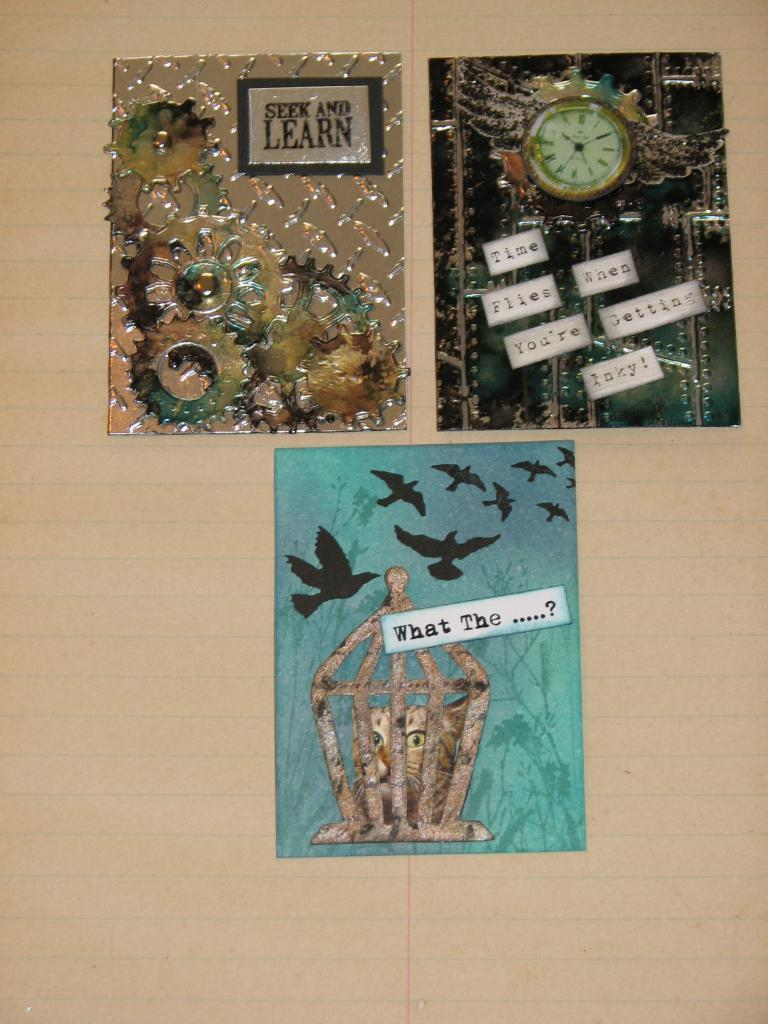<image>
Give a short and clear explanation of the subsequent image. A photo of three things on a sheet of notebook paper, the bottom one says What The ..... 